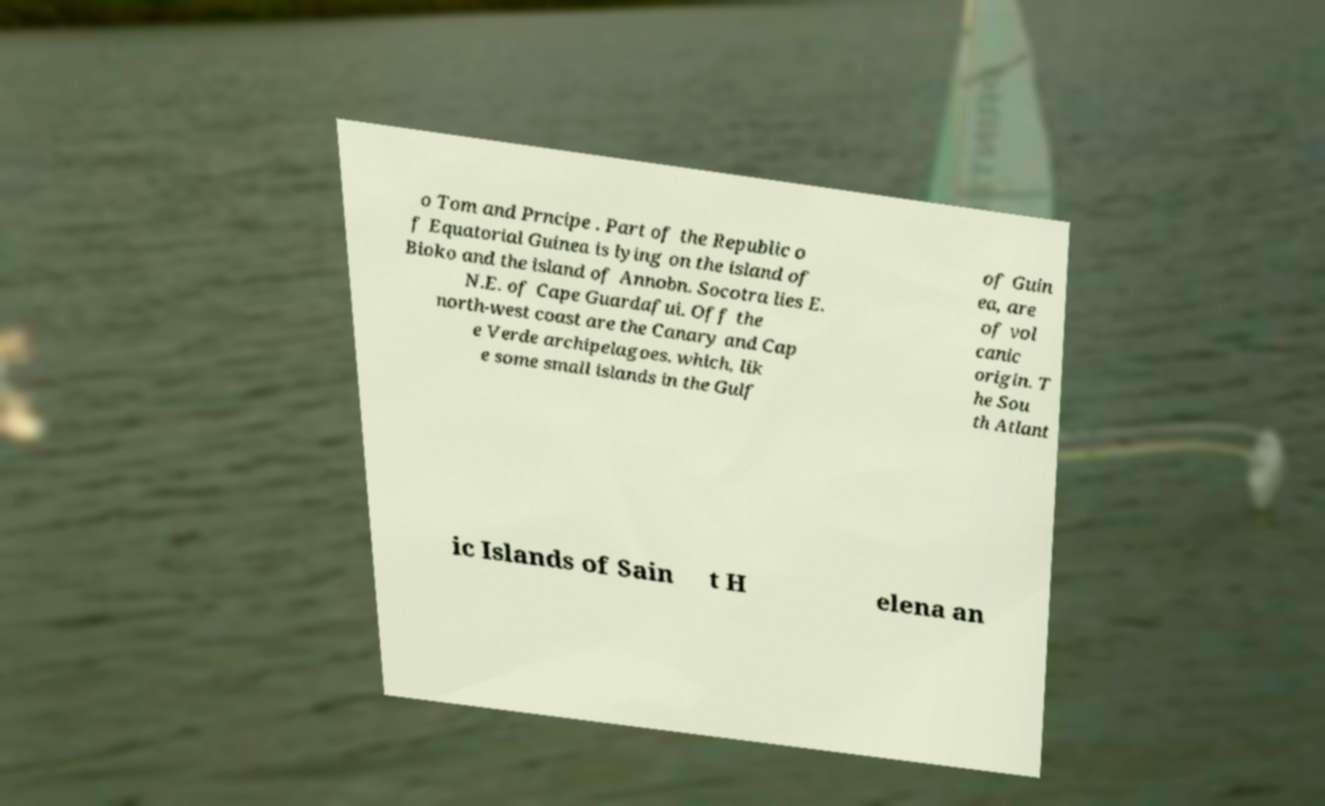There's text embedded in this image that I need extracted. Can you transcribe it verbatim? o Tom and Prncipe . Part of the Republic o f Equatorial Guinea is lying on the island of Bioko and the island of Annobn. Socotra lies E. N.E. of Cape Guardafui. Off the north-west coast are the Canary and Cap e Verde archipelagoes. which, lik e some small islands in the Gulf of Guin ea, are of vol canic origin. T he Sou th Atlant ic Islands of Sain t H elena an 